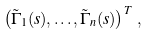Convert formula to latex. <formula><loc_0><loc_0><loc_500><loc_500>\left ( \tilde { \Gamma } _ { 1 } ( s ) , \dots , \tilde { \Gamma } _ { n } ( s ) \right ) ^ { T } \, ,</formula> 